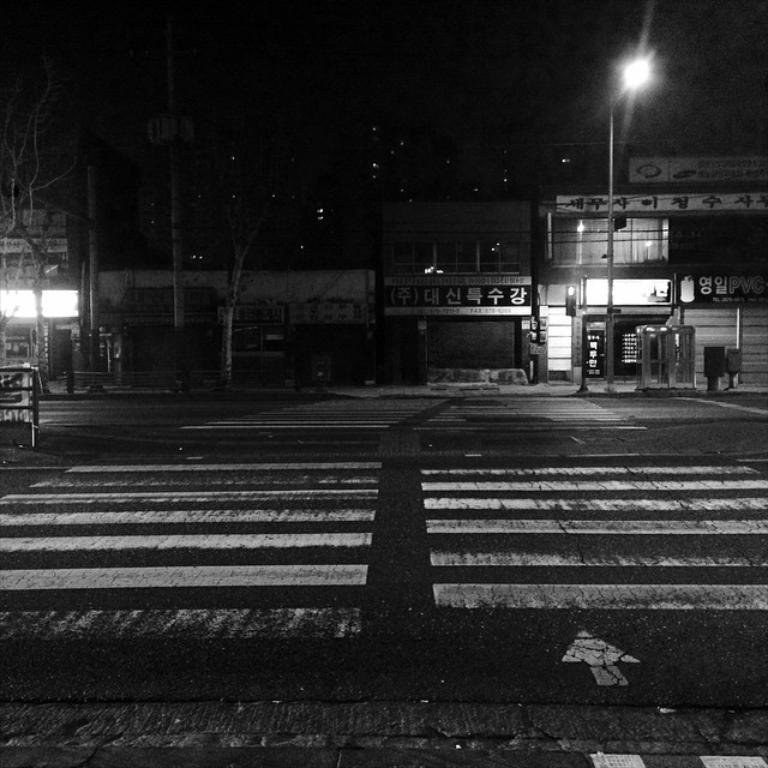What is the color scheme of the image? The image is black and white. What is one of the main features of the image? There is a road in the image. What type of objects can be seen near the road? There are bins and street poles visible in the image. What type of establishments are present in the image? There are stores in the image. How can the stores be identified? Name boards are present in the image. What else can be seen in the image? Trees and a street light are visible in the image. How many people are in the crowd gathered around the frog in the image? There is no crowd or frog present in the image. 